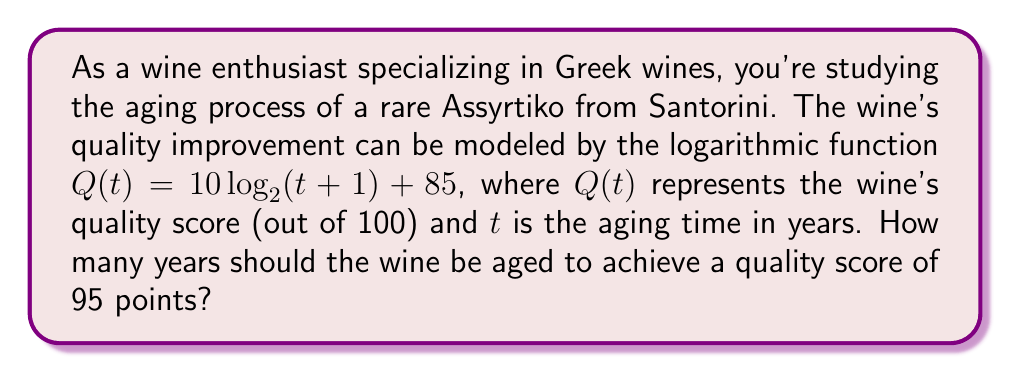Give your solution to this math problem. To solve this problem, we need to use the given logarithmic function and solve for $t$ when $Q(t) = 95$. Let's approach this step-by-step:

1) We start with the equation:
   $Q(t) = 10 \log_2(t+1) + 85$

2) We want to find $t$ when $Q(t) = 95$, so we substitute this:
   $95 = 10 \log_2(t+1) + 85$

3) Subtract 85 from both sides:
   $10 = 10 \log_2(t+1)$

4) Divide both sides by 10:
   $1 = \log_2(t+1)$

5) Now we can apply the inverse function, $2^x$, to both sides:
   $2^1 = 2^{\log_2(t+1)}$

6) Simplify:
   $2 = t+1$

7) Subtract 1 from both sides:
   $1 = t$

Therefore, the wine needs to be aged for 1 year to achieve a quality score of 95 points.

To verify:
$Q(1) = 10 \log_2(1+1) + 85 = 10 \log_2(2) + 85 = 10(1) + 85 = 95$
Answer: The wine should be aged for 1 year to achieve a quality score of 95 points. 